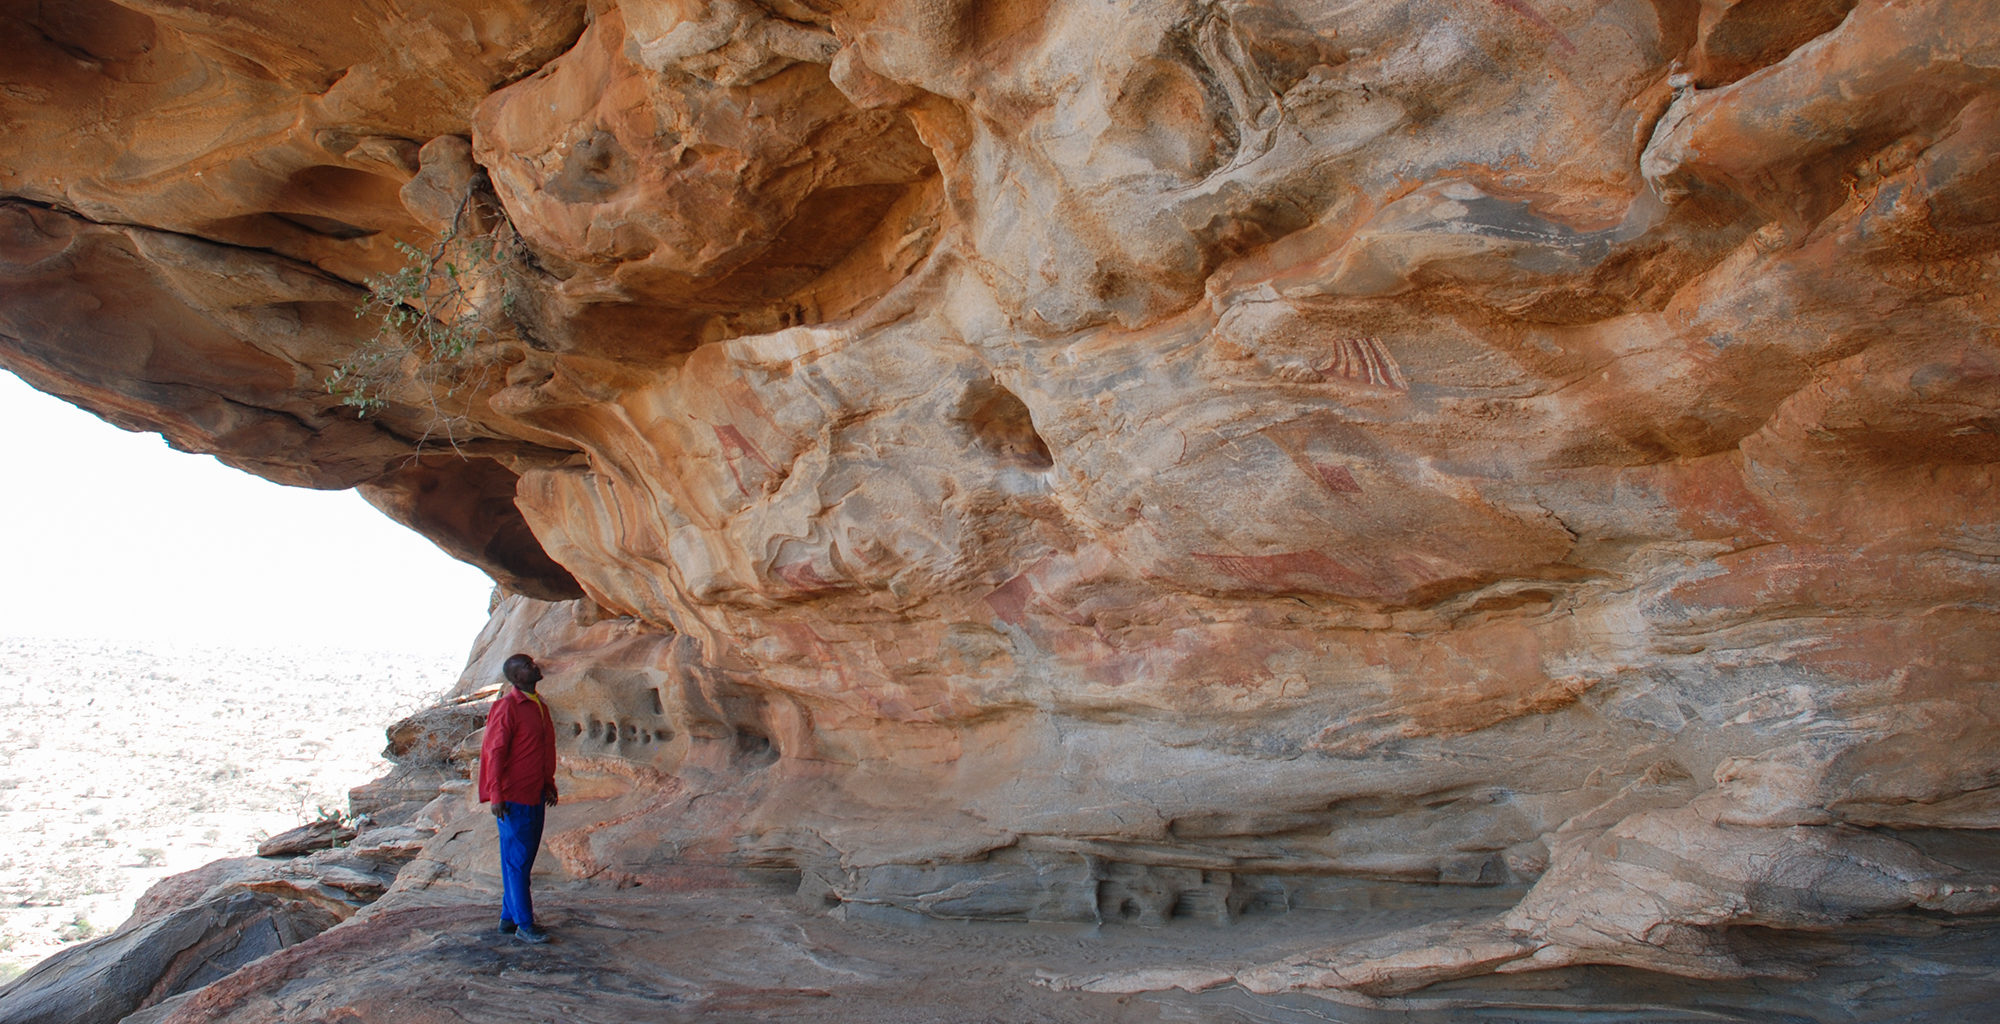What can you tell me about the person in the image? What might their thoughts be? The person in the image appears to be deeply engrossed in thought, perhaps reflecting on the significance of the ancient rock art before them. They might be contemplating the lives and stories of the people who created these artworks and marveling at their ability to tell their stories through such enduring and beautiful medium. The vastness of the desert surrounding them adds to their introspection, making them feel connected to a time long past while also appreciating the isolation and grandeur of the present moment. 